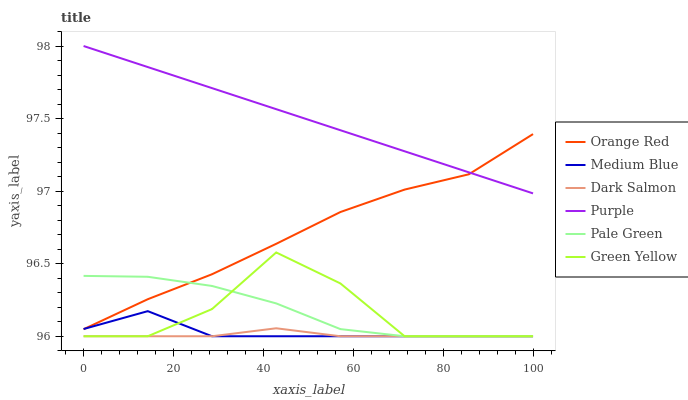Does Dark Salmon have the minimum area under the curve?
Answer yes or no. Yes. Does Purple have the maximum area under the curve?
Answer yes or no. Yes. Does Medium Blue have the minimum area under the curve?
Answer yes or no. No. Does Medium Blue have the maximum area under the curve?
Answer yes or no. No. Is Purple the smoothest?
Answer yes or no. Yes. Is Green Yellow the roughest?
Answer yes or no. Yes. Is Medium Blue the smoothest?
Answer yes or no. No. Is Medium Blue the roughest?
Answer yes or no. No. Does Medium Blue have the lowest value?
Answer yes or no. Yes. Does Orange Red have the lowest value?
Answer yes or no. No. Does Purple have the highest value?
Answer yes or no. Yes. Does Medium Blue have the highest value?
Answer yes or no. No. Is Pale Green less than Purple?
Answer yes or no. Yes. Is Purple greater than Pale Green?
Answer yes or no. Yes. Does Dark Salmon intersect Pale Green?
Answer yes or no. Yes. Is Dark Salmon less than Pale Green?
Answer yes or no. No. Is Dark Salmon greater than Pale Green?
Answer yes or no. No. Does Pale Green intersect Purple?
Answer yes or no. No. 